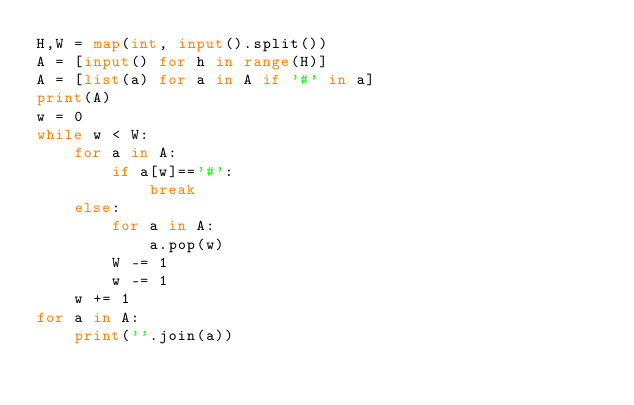<code> <loc_0><loc_0><loc_500><loc_500><_Python_>H,W = map(int, input().split())
A = [input() for h in range(H)]
A = [list(a) for a in A if '#' in a]
print(A)
w = 0
while w < W:
    for a in A:
        if a[w]=='#':
            break
    else:
        for a in A:
            a.pop(w)
        W -= 1
        w -= 1
    w += 1
for a in A:
    print(''.join(a))</code> 